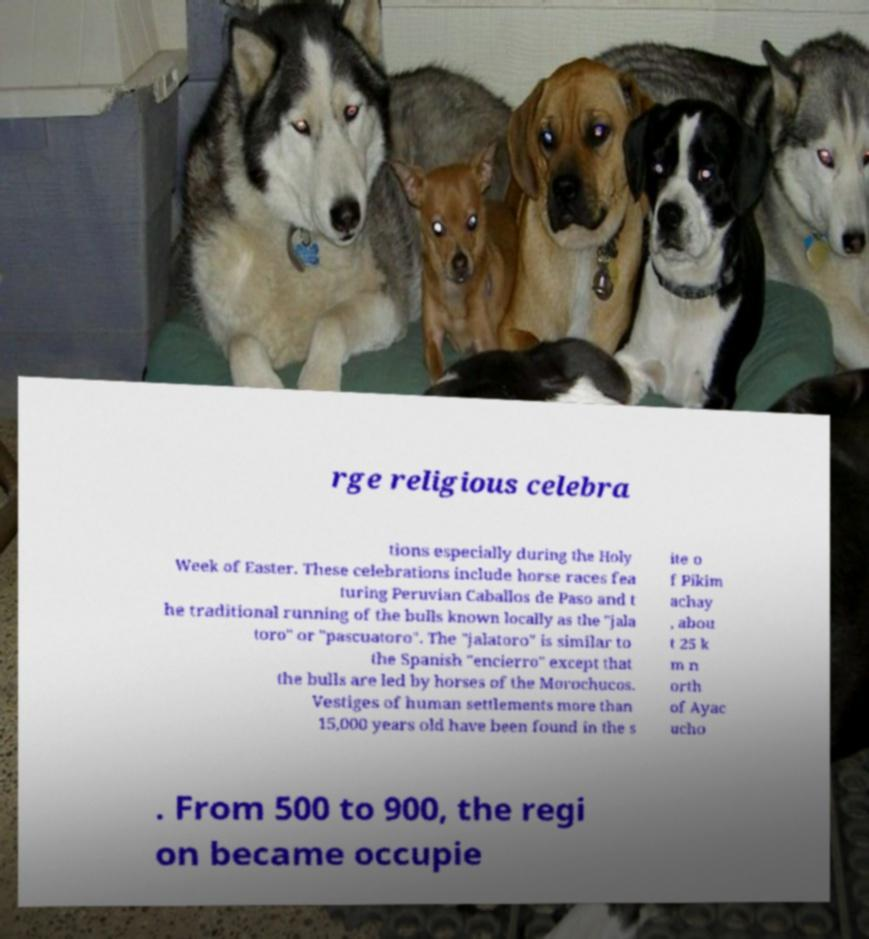I need the written content from this picture converted into text. Can you do that? rge religious celebra tions especially during the Holy Week of Easter. These celebrations include horse races fea turing Peruvian Caballos de Paso and t he traditional running of the bulls known locally as the "jala toro" or "pascuatoro". The "jalatoro" is similar to the Spanish "encierro" except that the bulls are led by horses of the Morochucos. Vestiges of human settlements more than 15,000 years old have been found in the s ite o f Pikim achay , abou t 25 k m n orth of Ayac ucho . From 500 to 900, the regi on became occupie 